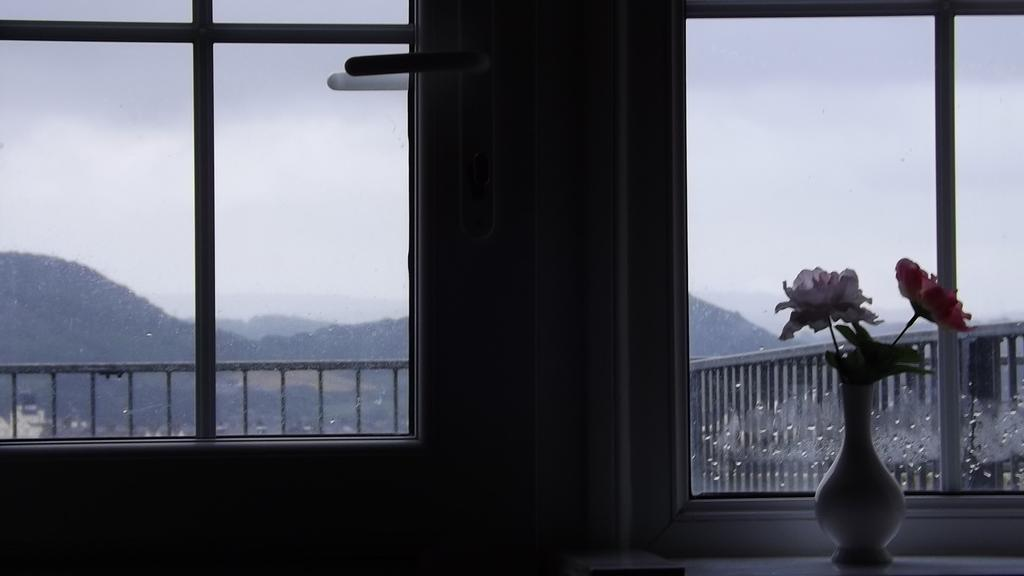What object is present in the image? There is a flower vase in the image. What can be seen in the background of the image? In the background of the image, there are windows, buildings, iron grills, hills, and the sky. Can you describe the setting of the image? The image appears to be taken outdoors, with a view of buildings, hills, and the sky in the background. Are there any fairies visible in the image? No, there are no fairies present in the image. What type of organization is responsible for the arrangement of the iron grills in the image? The image does not provide information about the organization responsible for the arrangement of the iron grills. 